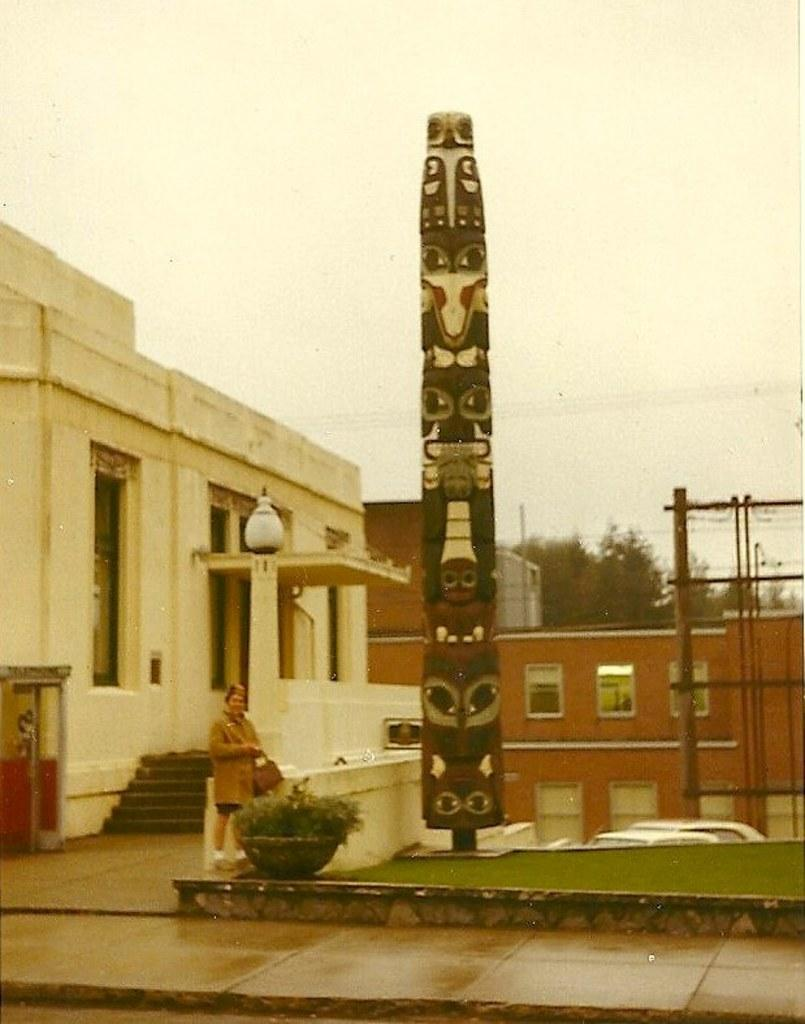What is the main subject in the image? There is a person standing in the image. What other objects or structures can be seen in the image? There is a statue, a potted plant, buildings, trees, and the sky is visible at the top of the image. Can the person in the image grant wishes? There is no indication in the image that the person has the ability to grant wishes. 